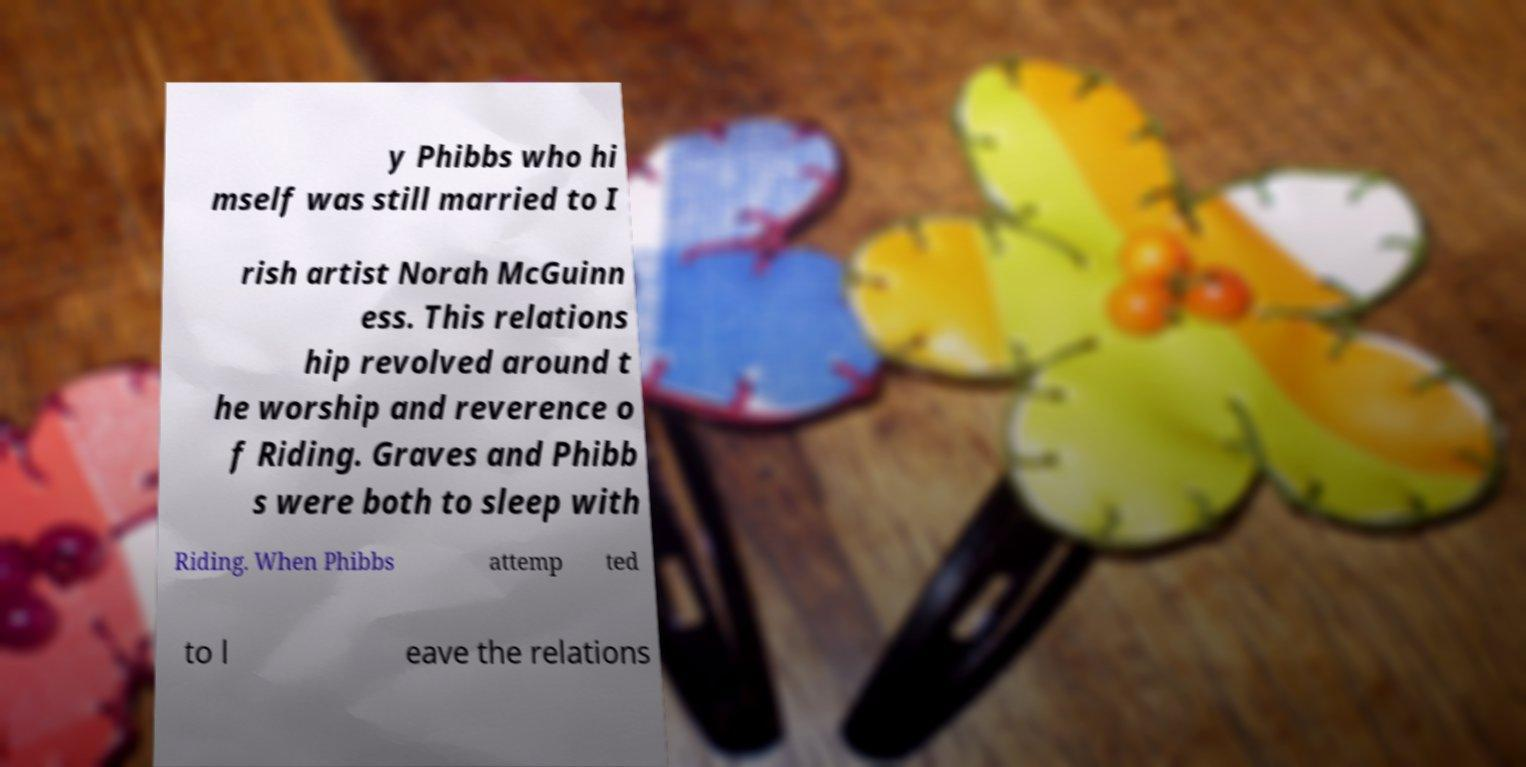Please identify and transcribe the text found in this image. y Phibbs who hi mself was still married to I rish artist Norah McGuinn ess. This relations hip revolved around t he worship and reverence o f Riding. Graves and Phibb s were both to sleep with Riding. When Phibbs attemp ted to l eave the relations 